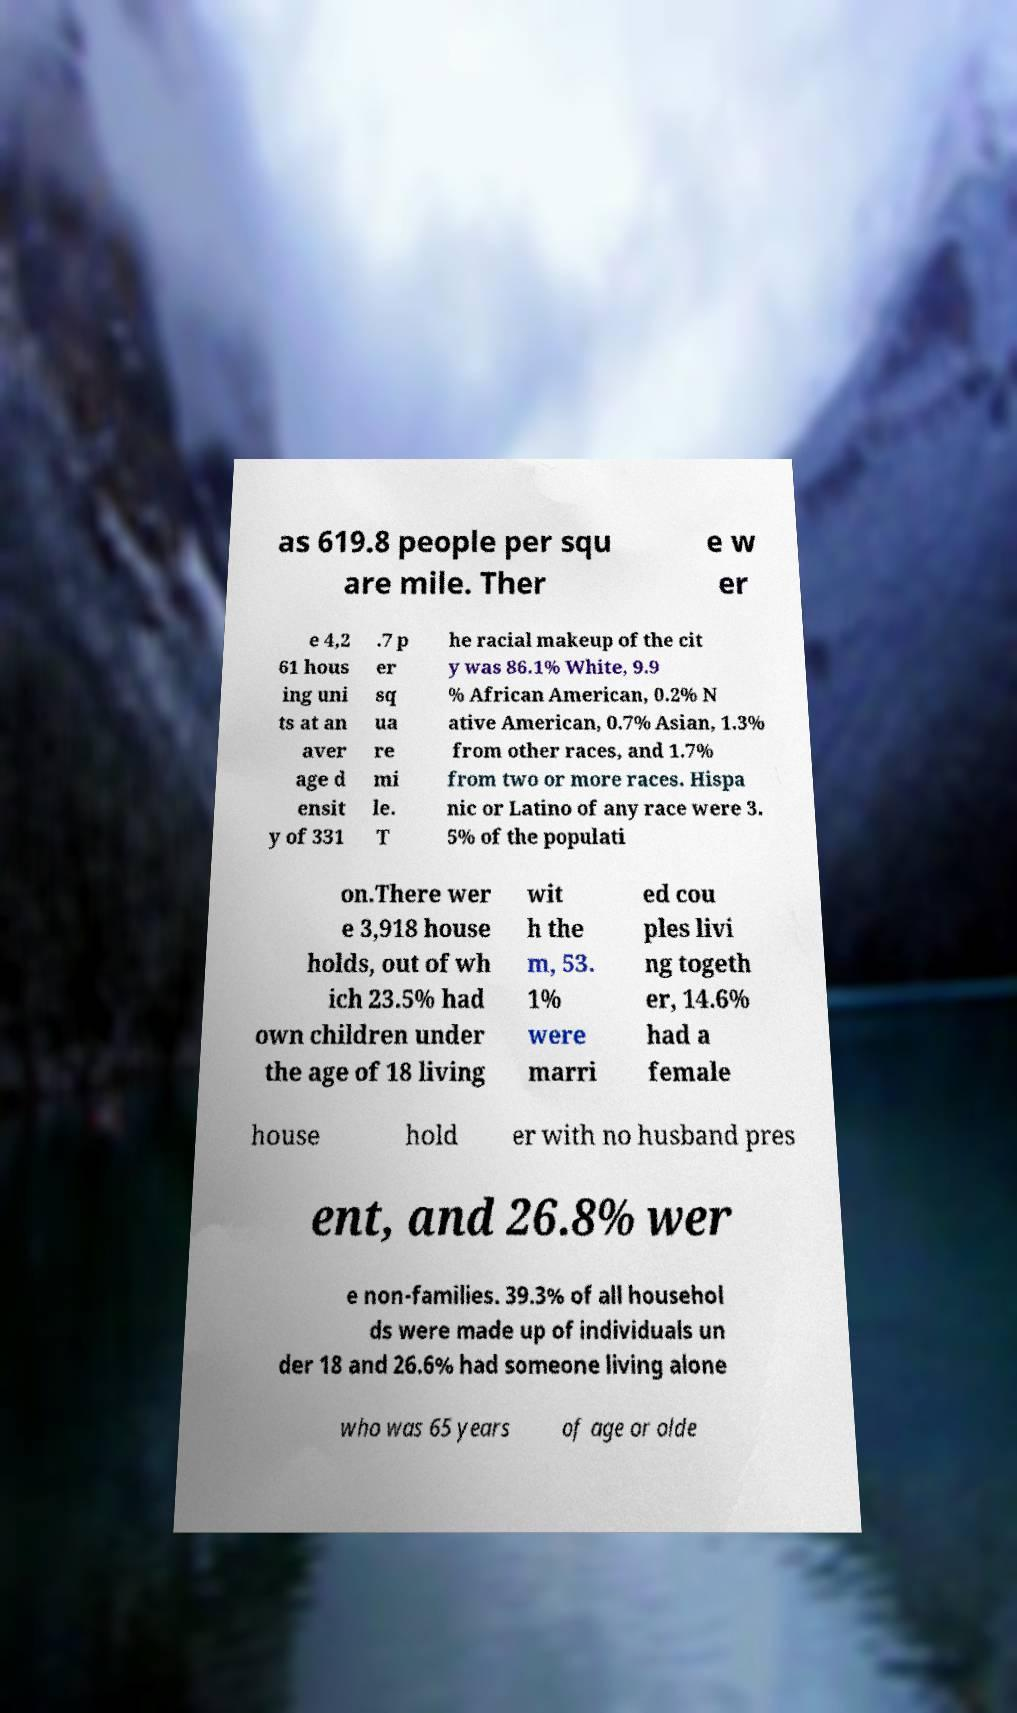Please identify and transcribe the text found in this image. as 619.8 people per squ are mile. Ther e w er e 4,2 61 hous ing uni ts at an aver age d ensit y of 331 .7 p er sq ua re mi le. T he racial makeup of the cit y was 86.1% White, 9.9 % African American, 0.2% N ative American, 0.7% Asian, 1.3% from other races, and 1.7% from two or more races. Hispa nic or Latino of any race were 3. 5% of the populati on.There wer e 3,918 house holds, out of wh ich 23.5% had own children under the age of 18 living wit h the m, 53. 1% were marri ed cou ples livi ng togeth er, 14.6% had a female house hold er with no husband pres ent, and 26.8% wer e non-families. 39.3% of all househol ds were made up of individuals un der 18 and 26.6% had someone living alone who was 65 years of age or olde 